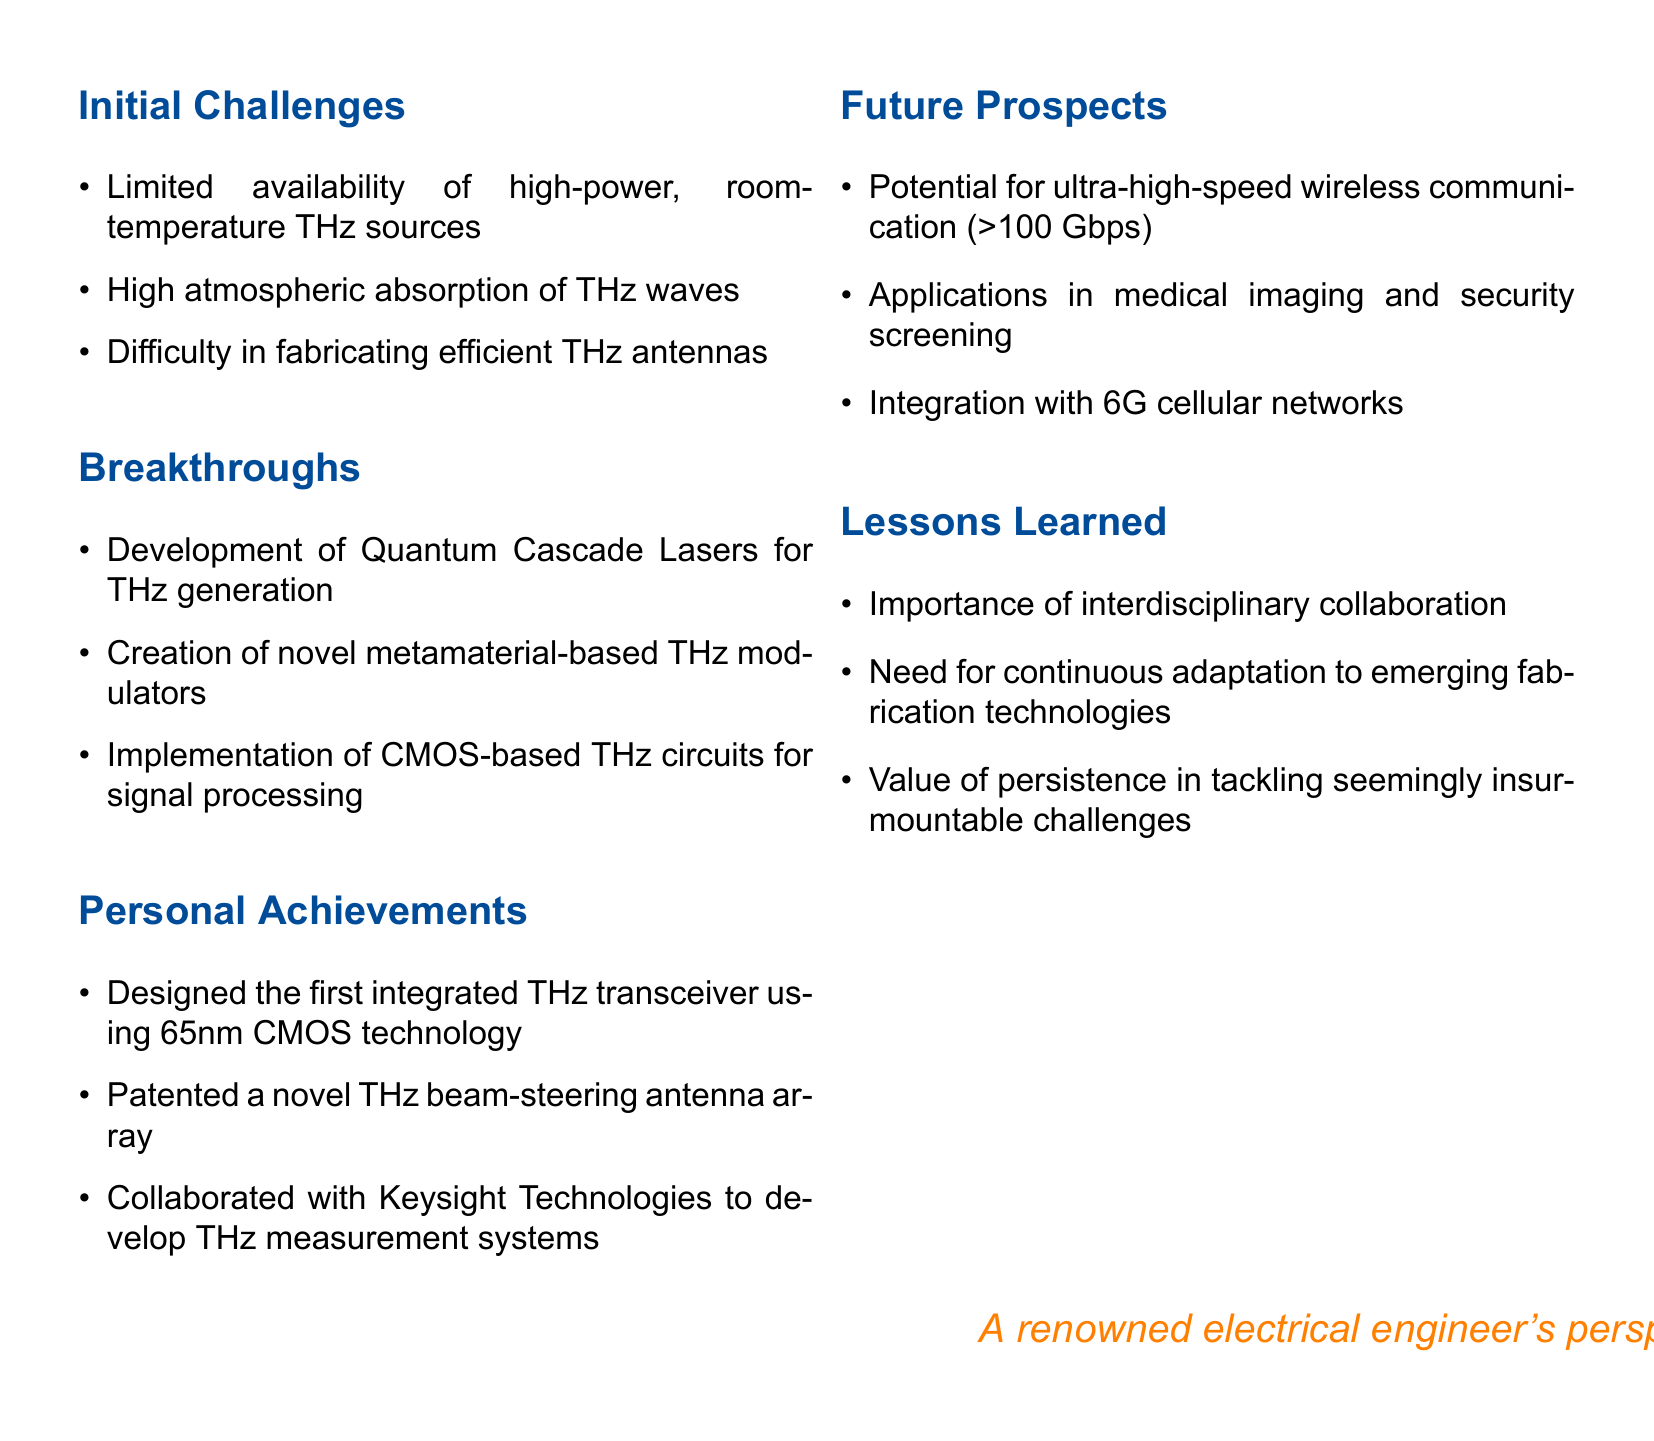What is the title of the document? The title is stated clearly at the top of the document.
Answer: Personal Reflections on Terahertz Communication Systems What technology was used to design the first integrated THz transceiver? The document specifies the technology used for the first integrated THz transceiver.
Answer: 65nm CMOS technology What breakthrough allows for THz generation? The document mentions a specific development that enables THz generation.
Answer: Quantum Cascade Lasers Which topic discusses the importance of interdisciplinary collaboration? The document lists key lessons learned, including a particular focus on collaboration.
Answer: Lessons Learned What is the potential speed for ultra-high-speed wireless communication mentioned? The document provides a specific figure related to communication speed.
Answer: Greater than 100 Gbps What is one application of terahertz communication systems mentioned? The document outlines potential applications for THz communication systems.
Answer: Medical imaging What kind of antenna was patented? The document details a specific type of antenna that was patented.
Answer: Beam-steering antenna array How many main topics are covered in the document? The document outlines several sections, each representing a main topic.
Answer: Five 